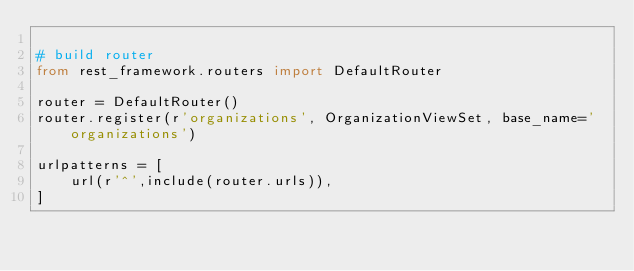<code> <loc_0><loc_0><loc_500><loc_500><_Python_>
# build router
from rest_framework.routers import DefaultRouter

router = DefaultRouter()
router.register(r'organizations', OrganizationViewSet, base_name='organizations')

urlpatterns = [
    url(r'^',include(router.urls)),
]</code> 